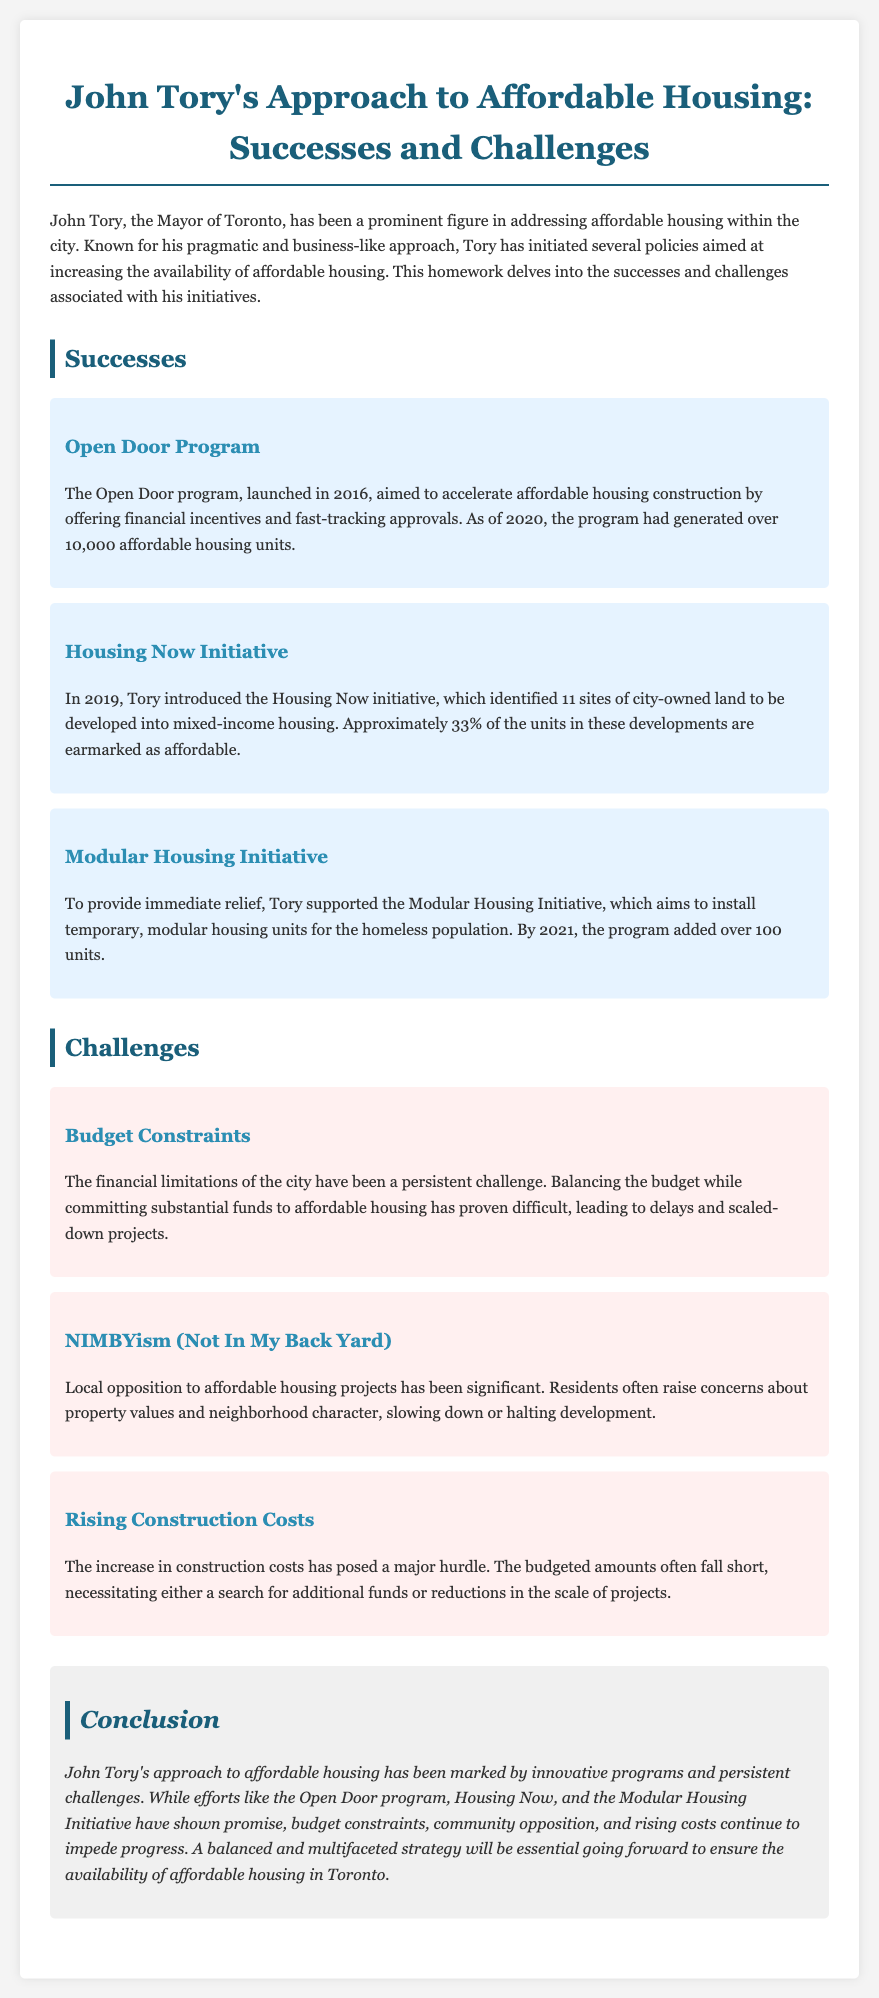What is the name of John Tory's housing initiative launched in 2016? The initiative launched in 2016 is aimed at accelerating affordable housing construction and is called the Open Door program.
Answer: Open Door program How many affordable housing units were generated by the Open Door program by 2020? The document states that the Open Door program had generated over 10,000 affordable housing units as of 2020.
Answer: over 10,000 What percentage of units in the Housing Now initiative are earmarked as affordable? The Housing Now initiative identified mixed-income housing where approximately 33% of the units are designated as affordable.
Answer: 33% What major challenge is caused by local residents opposing affordable housing projects? The opposition from local residents often raises concerns about property values and neighborhood character, which is referred to as NIMBYism.
Answer: NIMBYism By what year had the Modular Housing Initiative added over 100 units? The document mentions that by 2021, the Modular Housing Initiative had added over 100 units for the homeless population.
Answer: 2021 What persistent challenge does the city face regarding budget and funding for housing? Financial limitations are described as a persistent challenge that leads to delays and scaled-down projects in affordable housing.
Answer: Budget Constraints What is the general tone of John Tory's approach toward affordable housing, as described in the document? The document portrays John Tory's approach to affordable housing as pragmatic and business-like, reflecting a focus on practical solutions.
Answer: pragmatic What type of housing does the Modular Housing Initiative aim to provide? The Modular Housing Initiative seeks to provide temporary, modular housing units specifically for the homeless population.
Answer: temporary housing units What was the year when the Housing Now initiative was introduced? The document indicates that the Housing Now initiative was introduced in the year 2019.
Answer: 2019 